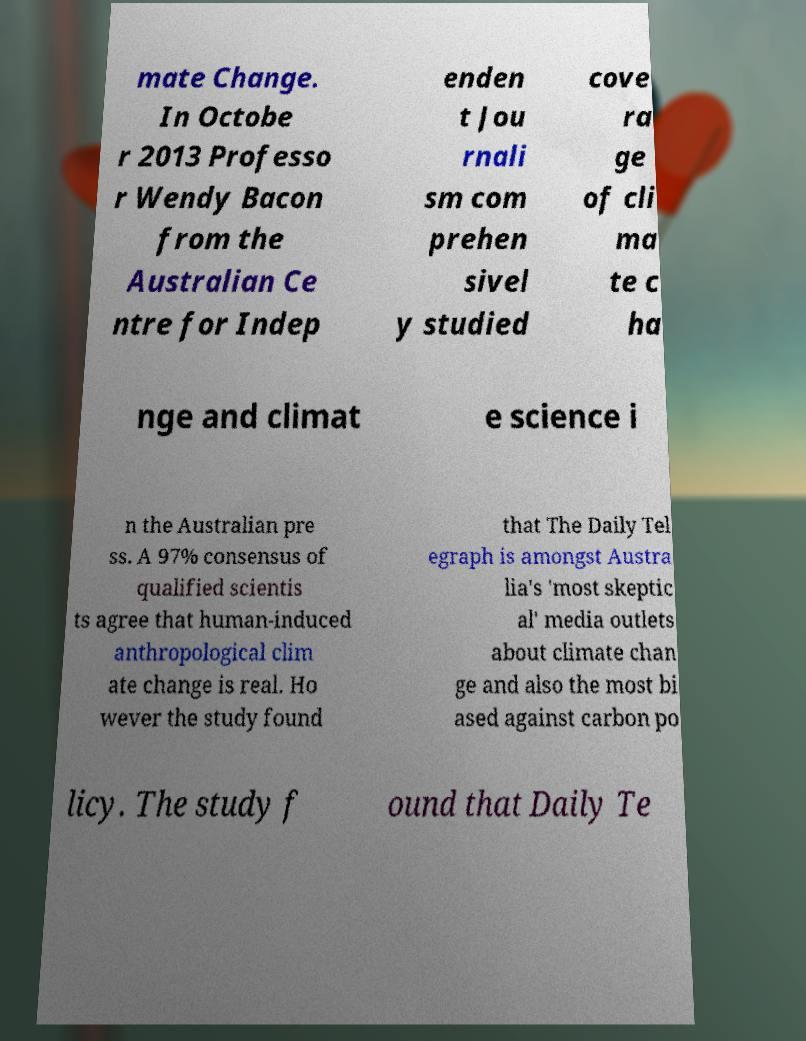There's text embedded in this image that I need extracted. Can you transcribe it verbatim? mate Change. In Octobe r 2013 Professo r Wendy Bacon from the Australian Ce ntre for Indep enden t Jou rnali sm com prehen sivel y studied cove ra ge of cli ma te c ha nge and climat e science i n the Australian pre ss. A 97% consensus of qualified scientis ts agree that human-induced anthropological clim ate change is real. Ho wever the study found that The Daily Tel egraph is amongst Austra lia's 'most skeptic al' media outlets about climate chan ge and also the most bi ased against carbon po licy. The study f ound that Daily Te 